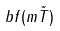<formula> <loc_0><loc_0><loc_500><loc_500>b f ( m \tilde { T } )</formula> 